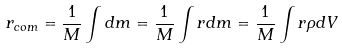<formula> <loc_0><loc_0><loc_500><loc_500>r _ { c o m } = { \frac { 1 } { M } } \int d m = { \frac { 1 } { M } } \int r d m = { \frac { 1 } { M } } \int r \rho d V</formula> 